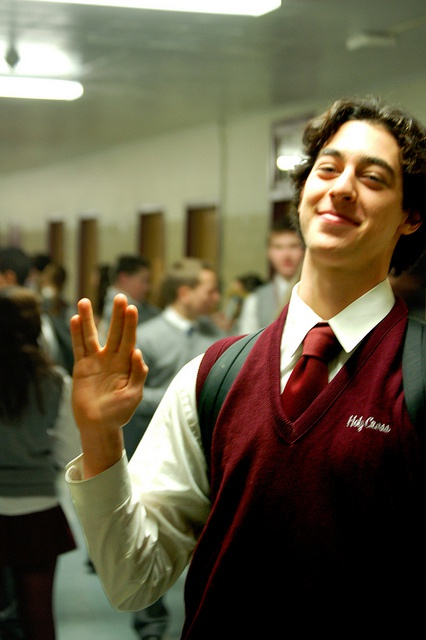Describe the objects in this image and their specific colors. I can see people in darkgray, black, maroon, olive, and ivory tones, people in darkgray, black, gray, and darkgreen tones, people in darkgray, olive, tan, and gray tones, backpack in darkgray, black, and darkgreen tones, and people in darkgray, tan, gray, and beige tones in this image. 